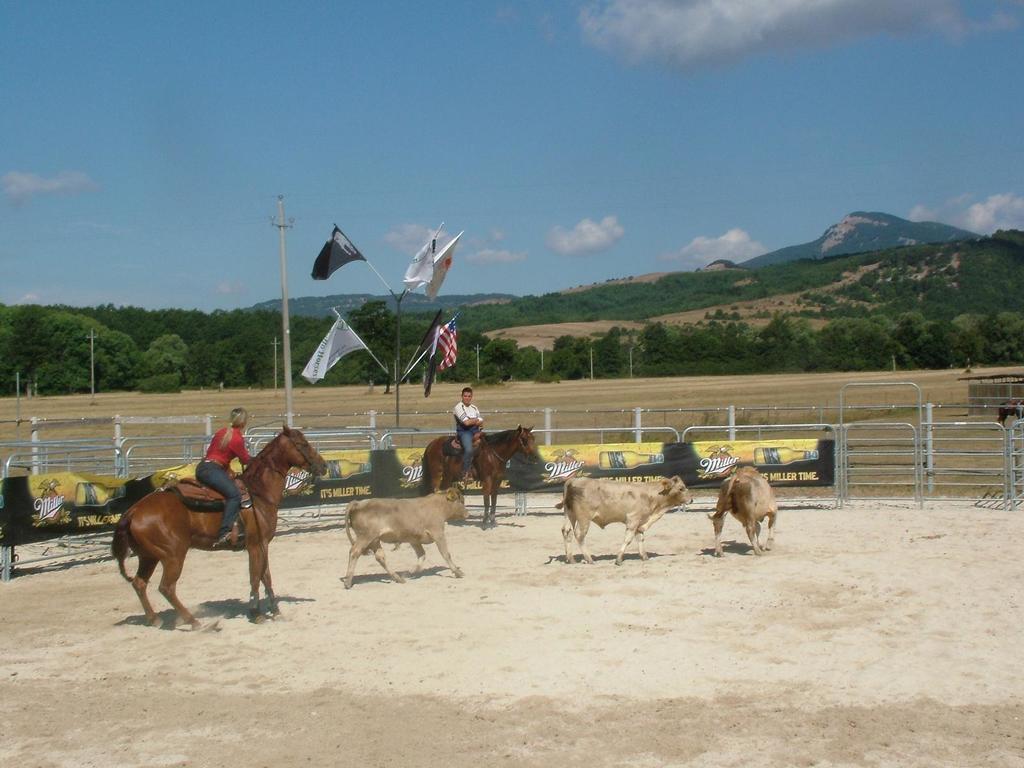Describe this image in one or two sentences. In this image we can see few animals in the ground, two persons are riding horses, there are banners to the iron railing, few flags to the stand and in the background there are trees, mountains and the sky with clouds. 